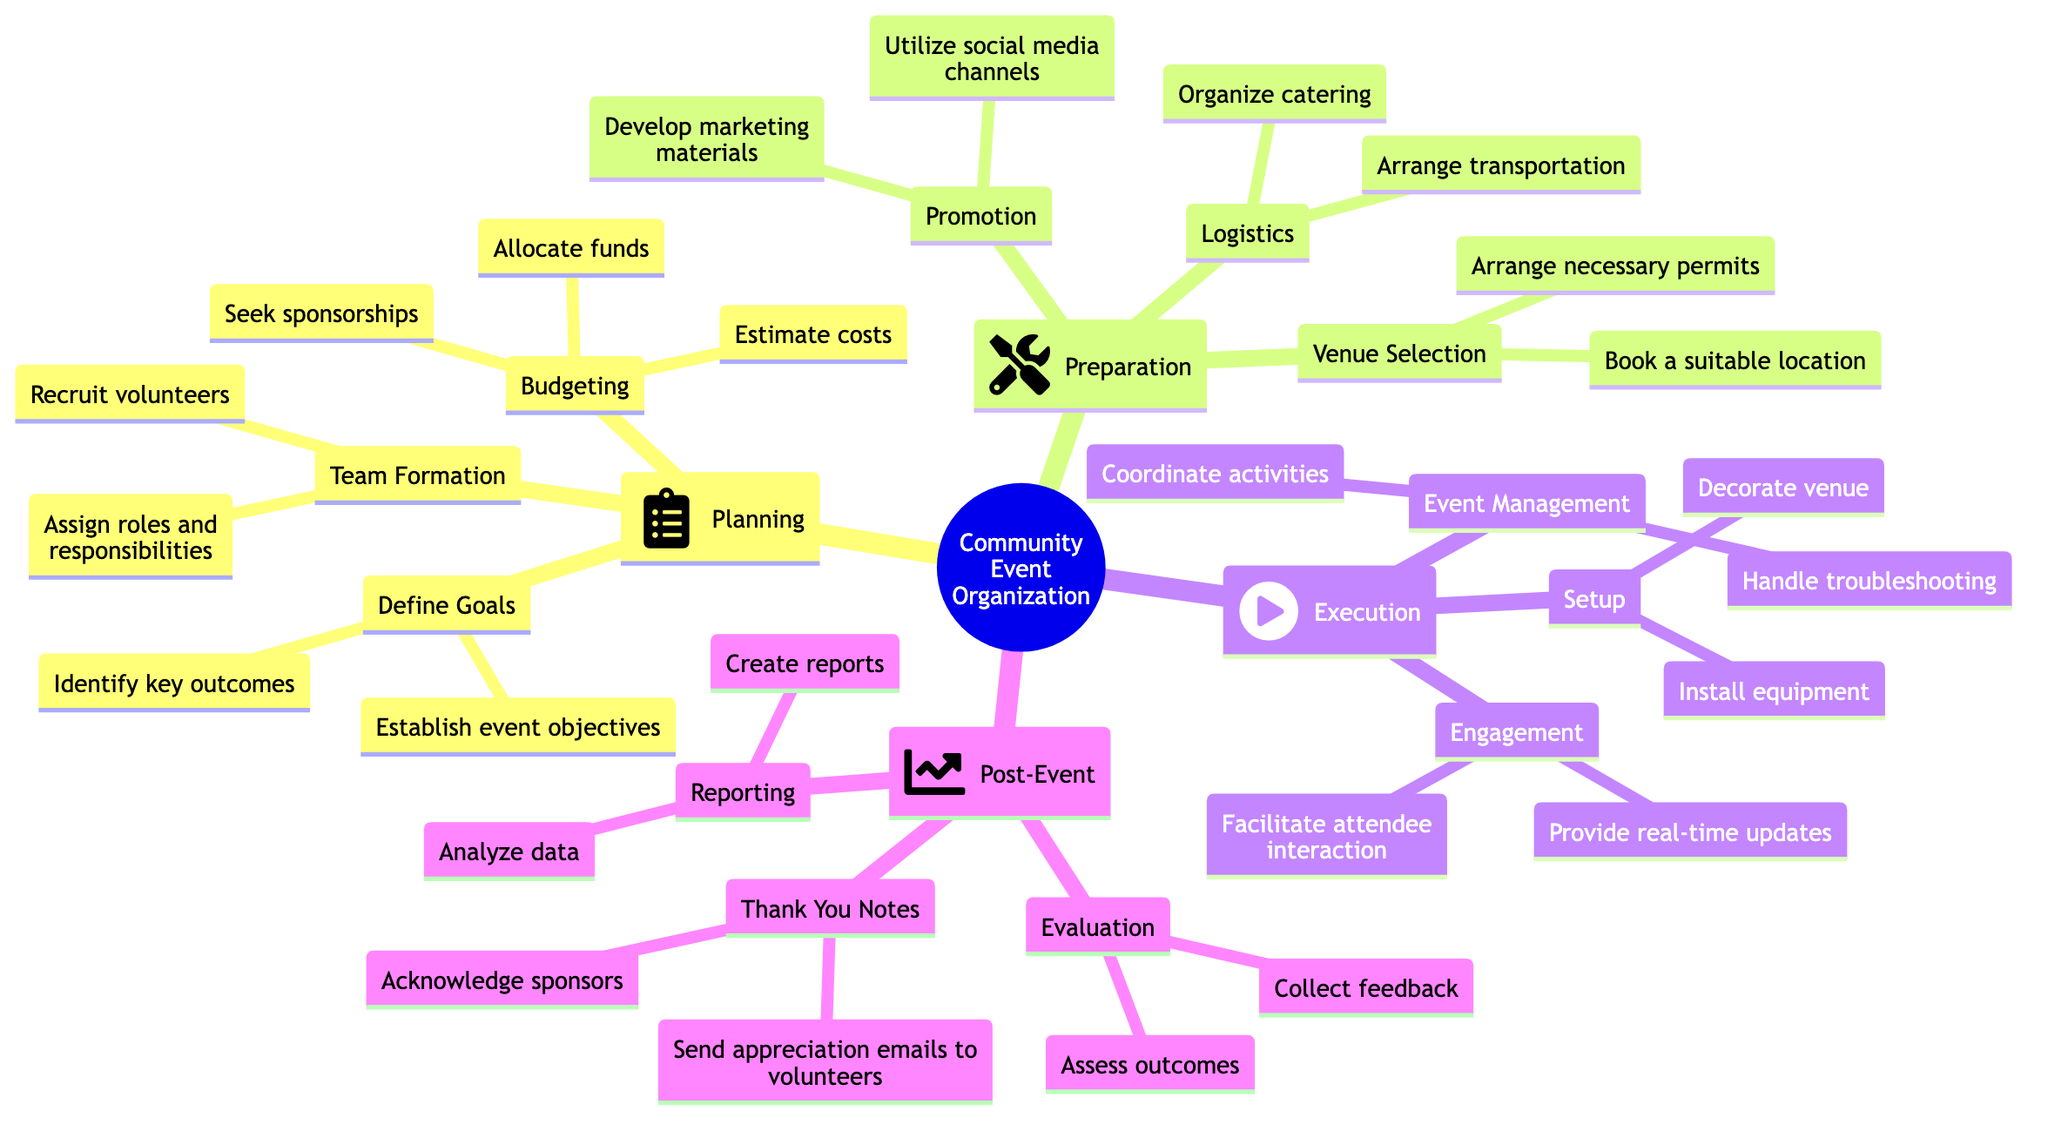What is the first step in organizing a community event? The diagram shows "Planning" as the first main step in the process of organizing a community event.
Answer: Planning How many subcategories are under the "Execution" step? The "Execution" step has three subcategories: "Setup," "Event Management," and "Engagement." Therefore, the count is three.
Answer: 3 What is one of the tasks in the "Preparation" phase? In the "Preparation" phase, one of the tasks is "Develop marketing materials."
Answer: Develop marketing materials Which step involves sending appreciation emails to volunteers? The "Thank You Notes" task is specifically responsible for sending appreciation emails to volunteers.
Answer: Thank You Notes In the "Post-Event" phase, what is one way to assess outcomes? One method to assess outcomes in the "Post-Event" phase is to "Collect feedback."
Answer: Collect feedback What type of materials are developed during the "Promotion" stage? During the "Promotion" stage, "marketing materials" are developed as part of the tasks outlined.
Answer: Marketing materials Which process requires booking a suitable location? The process of "Venue Selection" requires booking a suitable location as part of its tasks.
Answer: Venue Selection How many tasks are listed under "Team Formation"? Under "Team Formation," there are two tasks listed: "Assign roles and responsibilities" and "Recruit volunteers," thus the total is two.
Answer: 2 What is the focus of the "Engagement" task in the "Execution" phase? The focus of the "Engagement" task is to "Facilitate attendee interaction" and "Provide real-time updates," highlighting its role in participant involvement.
Answer: Facilitate attendee interaction What indicates the relationship between "Budgeting" and "Define Goals"? "Budgeting" is categorized under "Planning," which connects it directly to "Define Goals" since both are part of the same primary step in the organization process.
Answer: Planning 